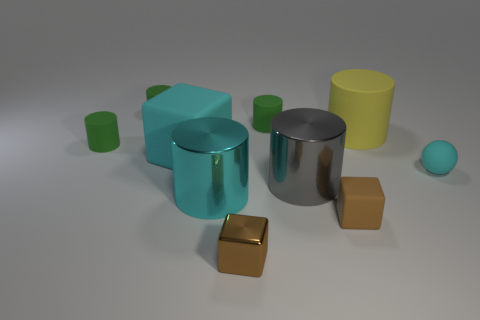There is a gray object that is the same shape as the yellow rubber thing; what is it made of?
Ensure brevity in your answer.  Metal. There is a tiny cylinder that is right of the tiny brown metal cube; what color is it?
Provide a succinct answer. Green. What number of blue things are shiny cylinders or big rubber cubes?
Offer a very short reply. 0. The small metal object is what color?
Provide a short and direct response. Brown. Are there fewer large yellow things in front of the shiny block than big rubber objects to the right of the large cyan rubber cube?
Offer a terse response. Yes. What is the shape of the rubber thing that is both on the left side of the large gray metallic cylinder and right of the tiny shiny thing?
Offer a very short reply. Cylinder. What number of other rubber objects are the same shape as the large cyan matte thing?
Give a very brief answer. 1. What is the size of the sphere that is the same material as the big yellow object?
Provide a succinct answer. Small. What number of cyan spheres are the same size as the shiny block?
Provide a short and direct response. 1. What is the size of the thing that is the same color as the metallic cube?
Keep it short and to the point. Small. 